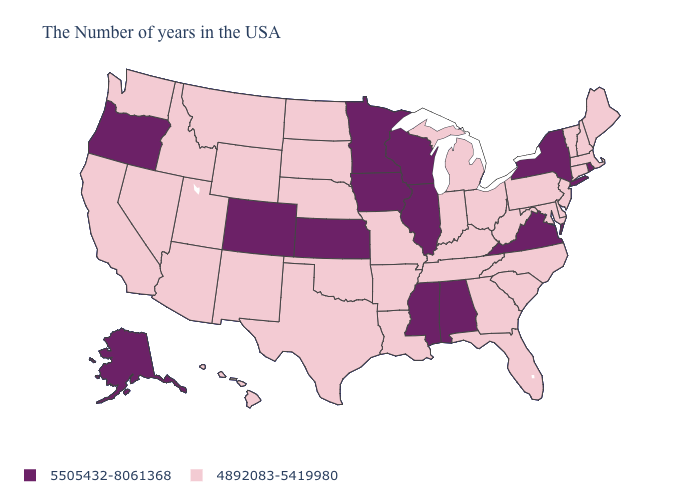Does the map have missing data?
Be succinct. No. Name the states that have a value in the range 4892083-5419980?
Short answer required. Maine, Massachusetts, New Hampshire, Vermont, Connecticut, New Jersey, Delaware, Maryland, Pennsylvania, North Carolina, South Carolina, West Virginia, Ohio, Florida, Georgia, Michigan, Kentucky, Indiana, Tennessee, Louisiana, Missouri, Arkansas, Nebraska, Oklahoma, Texas, South Dakota, North Dakota, Wyoming, New Mexico, Utah, Montana, Arizona, Idaho, Nevada, California, Washington, Hawaii. Among the states that border Kansas , which have the highest value?
Give a very brief answer. Colorado. Which states hav the highest value in the West?
Answer briefly. Colorado, Oregon, Alaska. What is the value of New York?
Write a very short answer. 5505432-8061368. Does Utah have the lowest value in the USA?
Write a very short answer. Yes. What is the value of Wisconsin?
Give a very brief answer. 5505432-8061368. Does Wisconsin have the highest value in the MidWest?
Keep it brief. Yes. What is the highest value in the MidWest ?
Write a very short answer. 5505432-8061368. Which states have the lowest value in the USA?
Concise answer only. Maine, Massachusetts, New Hampshire, Vermont, Connecticut, New Jersey, Delaware, Maryland, Pennsylvania, North Carolina, South Carolina, West Virginia, Ohio, Florida, Georgia, Michigan, Kentucky, Indiana, Tennessee, Louisiana, Missouri, Arkansas, Nebraska, Oklahoma, Texas, South Dakota, North Dakota, Wyoming, New Mexico, Utah, Montana, Arizona, Idaho, Nevada, California, Washington, Hawaii. What is the highest value in the USA?
Give a very brief answer. 5505432-8061368. Name the states that have a value in the range 4892083-5419980?
Concise answer only. Maine, Massachusetts, New Hampshire, Vermont, Connecticut, New Jersey, Delaware, Maryland, Pennsylvania, North Carolina, South Carolina, West Virginia, Ohio, Florida, Georgia, Michigan, Kentucky, Indiana, Tennessee, Louisiana, Missouri, Arkansas, Nebraska, Oklahoma, Texas, South Dakota, North Dakota, Wyoming, New Mexico, Utah, Montana, Arizona, Idaho, Nevada, California, Washington, Hawaii. Which states have the lowest value in the USA?
Answer briefly. Maine, Massachusetts, New Hampshire, Vermont, Connecticut, New Jersey, Delaware, Maryland, Pennsylvania, North Carolina, South Carolina, West Virginia, Ohio, Florida, Georgia, Michigan, Kentucky, Indiana, Tennessee, Louisiana, Missouri, Arkansas, Nebraska, Oklahoma, Texas, South Dakota, North Dakota, Wyoming, New Mexico, Utah, Montana, Arizona, Idaho, Nevada, California, Washington, Hawaii. Does Montana have the lowest value in the West?
Short answer required. Yes. Which states hav the highest value in the West?
Keep it brief. Colorado, Oregon, Alaska. 